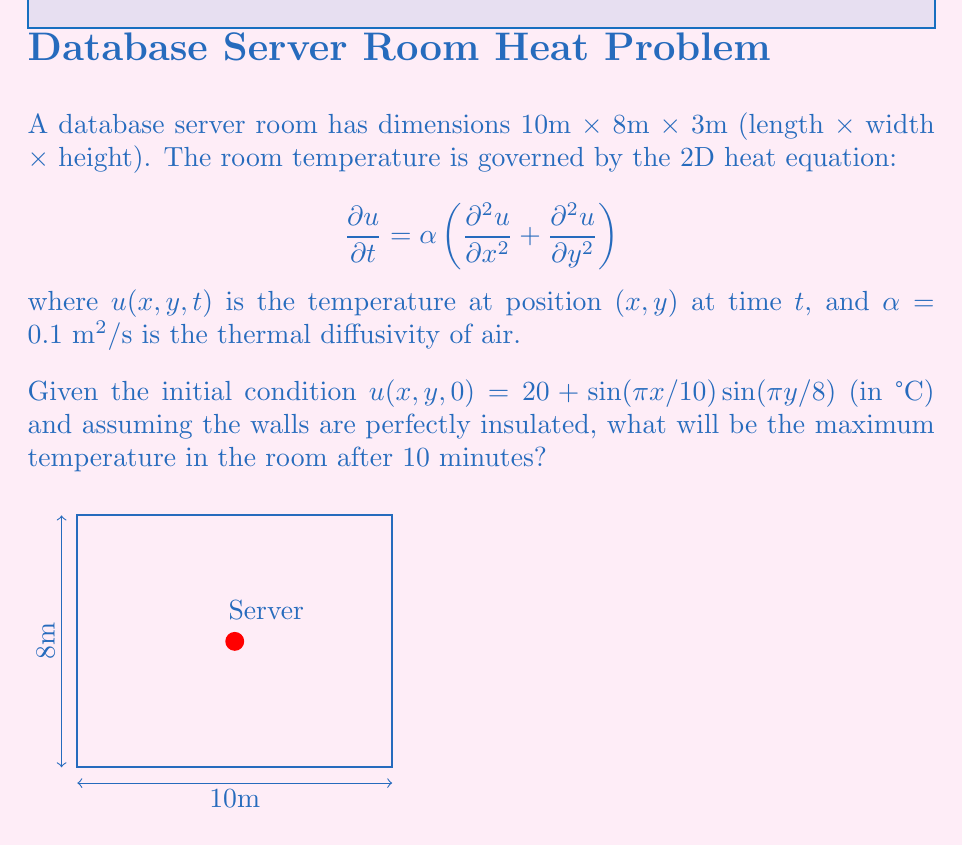What is the answer to this math problem? To solve this problem, we'll follow these steps:

1) The general solution to the 2D heat equation with insulated boundaries is:

   $$u(x,y,t) = \sum_{m=0}^{\infty}\sum_{n=0}^{\infty} A_{mn} \cos(\frac{m\pi x}{L_x})\cos(\frac{n\pi y}{L_y})e^{-\alpha t(\frac{m^2\pi^2}{L_x^2}+\frac{n^2\pi^2}{L_y^2})}$$

   where $L_x = 10$ and $L_y = 8$ are the room dimensions.

2) Given the initial condition, we can see that it matches the form of the solution with $m=1$, $n=1$, and $A_{11} = 1$. The constant term 20 corresponds to $A_{00} = 20$. So our solution is:

   $$u(x,y,t) = 20 + \sin(\frac{\pi x}{10})\sin(\frac{\pi y}{8})e^{-\alpha t(\frac{\pi^2}{100}+\frac{\pi^2}{64})}$$

3) To find the maximum temperature after 10 minutes (600 seconds), we need to evaluate:

   $$u_{max} = 20 + e^{-0.1 \cdot 600 \cdot (\frac{\pi^2}{100}+\frac{\pi^2}{64})}$$

4) Calculating the exponent:
   $$0.1 \cdot 600 \cdot (\frac{\pi^2}{100}+\frac{\pi^2}{64}) \approx 11.9$$

5) Therefore:
   $$u_{max} = 20 + e^{-11.9} \approx 20.000006821$$

The maximum temperature occurs where $\sin(\frac{\pi x}{10})\sin(\frac{\pi y}{8})$ is maximum, which is at the center of the room.
Answer: 20.000007°C 